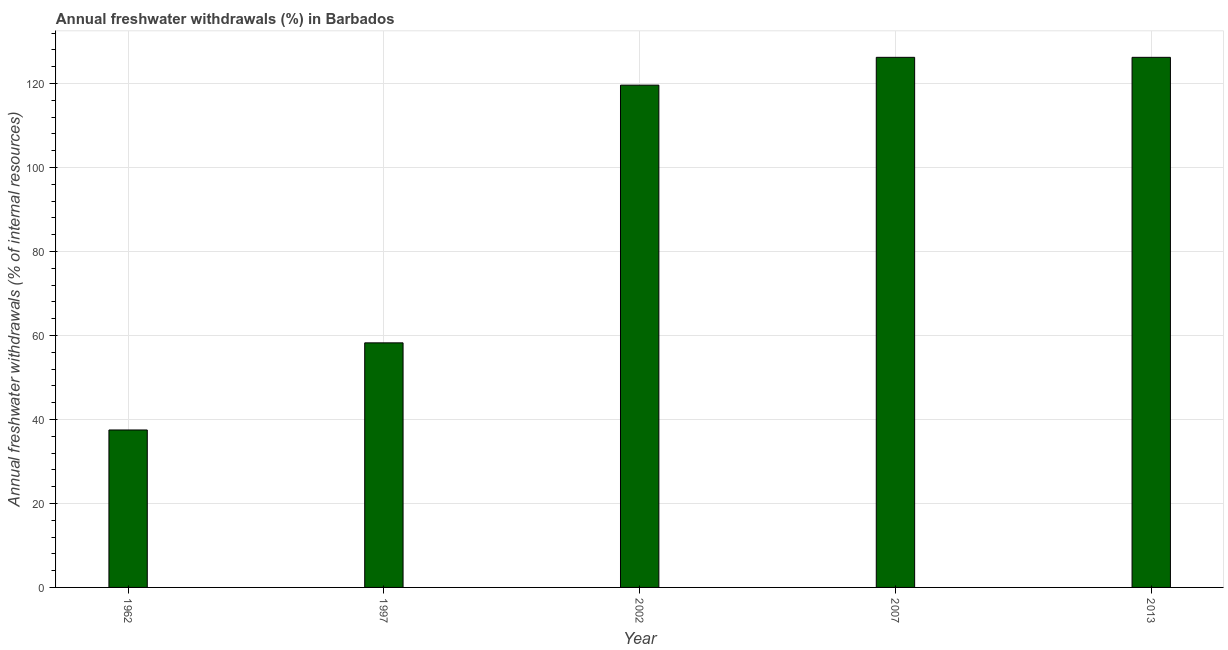Does the graph contain any zero values?
Your answer should be very brief. No. What is the title of the graph?
Your response must be concise. Annual freshwater withdrawals (%) in Barbados. What is the label or title of the X-axis?
Offer a terse response. Year. What is the label or title of the Y-axis?
Your answer should be very brief. Annual freshwater withdrawals (% of internal resources). What is the annual freshwater withdrawals in 2002?
Offer a very short reply. 119.62. Across all years, what is the maximum annual freshwater withdrawals?
Provide a short and direct response. 126.25. Across all years, what is the minimum annual freshwater withdrawals?
Offer a terse response. 37.5. In which year was the annual freshwater withdrawals maximum?
Give a very brief answer. 2007. In which year was the annual freshwater withdrawals minimum?
Provide a short and direct response. 1962. What is the sum of the annual freshwater withdrawals?
Make the answer very short. 467.88. What is the difference between the annual freshwater withdrawals in 2002 and 2007?
Offer a very short reply. -6.62. What is the average annual freshwater withdrawals per year?
Keep it short and to the point. 93.58. What is the median annual freshwater withdrawals?
Offer a terse response. 119.62. Do a majority of the years between 2002 and 2013 (inclusive) have annual freshwater withdrawals greater than 40 %?
Make the answer very short. Yes. What is the ratio of the annual freshwater withdrawals in 1962 to that in 1997?
Your answer should be compact. 0.64. What is the difference between the highest and the lowest annual freshwater withdrawals?
Your response must be concise. 88.75. How many bars are there?
Your answer should be very brief. 5. What is the difference between two consecutive major ticks on the Y-axis?
Make the answer very short. 20. Are the values on the major ticks of Y-axis written in scientific E-notation?
Provide a short and direct response. No. What is the Annual freshwater withdrawals (% of internal resources) in 1962?
Give a very brief answer. 37.5. What is the Annual freshwater withdrawals (% of internal resources) of 1997?
Give a very brief answer. 58.25. What is the Annual freshwater withdrawals (% of internal resources) of 2002?
Give a very brief answer. 119.62. What is the Annual freshwater withdrawals (% of internal resources) of 2007?
Offer a terse response. 126.25. What is the Annual freshwater withdrawals (% of internal resources) in 2013?
Make the answer very short. 126.25. What is the difference between the Annual freshwater withdrawals (% of internal resources) in 1962 and 1997?
Provide a short and direct response. -20.75. What is the difference between the Annual freshwater withdrawals (% of internal resources) in 1962 and 2002?
Give a very brief answer. -82.12. What is the difference between the Annual freshwater withdrawals (% of internal resources) in 1962 and 2007?
Give a very brief answer. -88.75. What is the difference between the Annual freshwater withdrawals (% of internal resources) in 1962 and 2013?
Offer a very short reply. -88.75. What is the difference between the Annual freshwater withdrawals (% of internal resources) in 1997 and 2002?
Keep it short and to the point. -61.38. What is the difference between the Annual freshwater withdrawals (% of internal resources) in 1997 and 2007?
Keep it short and to the point. -68. What is the difference between the Annual freshwater withdrawals (% of internal resources) in 1997 and 2013?
Offer a very short reply. -68. What is the difference between the Annual freshwater withdrawals (% of internal resources) in 2002 and 2007?
Ensure brevity in your answer.  -6.62. What is the difference between the Annual freshwater withdrawals (% of internal resources) in 2002 and 2013?
Your answer should be very brief. -6.62. What is the difference between the Annual freshwater withdrawals (% of internal resources) in 2007 and 2013?
Offer a very short reply. 0. What is the ratio of the Annual freshwater withdrawals (% of internal resources) in 1962 to that in 1997?
Keep it short and to the point. 0.64. What is the ratio of the Annual freshwater withdrawals (% of internal resources) in 1962 to that in 2002?
Your answer should be compact. 0.31. What is the ratio of the Annual freshwater withdrawals (% of internal resources) in 1962 to that in 2007?
Your answer should be compact. 0.3. What is the ratio of the Annual freshwater withdrawals (% of internal resources) in 1962 to that in 2013?
Provide a succinct answer. 0.3. What is the ratio of the Annual freshwater withdrawals (% of internal resources) in 1997 to that in 2002?
Your response must be concise. 0.49. What is the ratio of the Annual freshwater withdrawals (% of internal resources) in 1997 to that in 2007?
Keep it short and to the point. 0.46. What is the ratio of the Annual freshwater withdrawals (% of internal resources) in 1997 to that in 2013?
Provide a short and direct response. 0.46. What is the ratio of the Annual freshwater withdrawals (% of internal resources) in 2002 to that in 2007?
Your response must be concise. 0.95. What is the ratio of the Annual freshwater withdrawals (% of internal resources) in 2002 to that in 2013?
Ensure brevity in your answer.  0.95. What is the ratio of the Annual freshwater withdrawals (% of internal resources) in 2007 to that in 2013?
Your response must be concise. 1. 